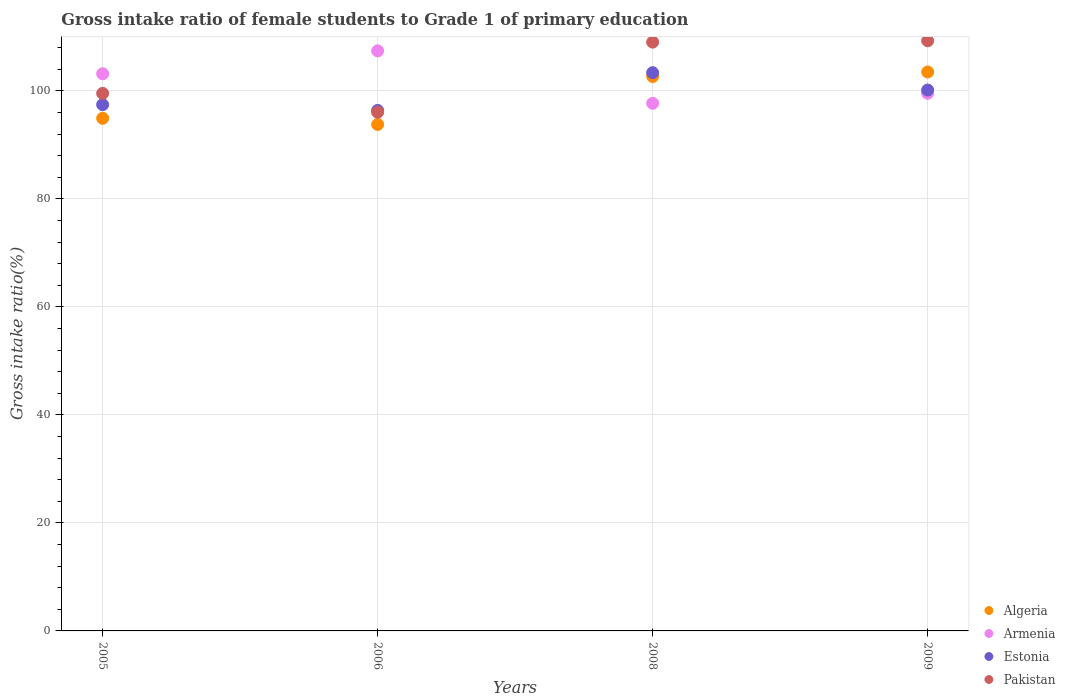How many different coloured dotlines are there?
Give a very brief answer. 4. Is the number of dotlines equal to the number of legend labels?
Your answer should be compact. Yes. What is the gross intake ratio in Armenia in 2006?
Your response must be concise. 107.41. Across all years, what is the maximum gross intake ratio in Armenia?
Your answer should be very brief. 107.41. Across all years, what is the minimum gross intake ratio in Estonia?
Your answer should be very brief. 96.38. In which year was the gross intake ratio in Pakistan maximum?
Give a very brief answer. 2009. What is the total gross intake ratio in Pakistan in the graph?
Offer a terse response. 413.89. What is the difference between the gross intake ratio in Estonia in 2005 and that in 2006?
Offer a terse response. 1.06. What is the difference between the gross intake ratio in Pakistan in 2006 and the gross intake ratio in Algeria in 2008?
Make the answer very short. -6.61. What is the average gross intake ratio in Armenia per year?
Provide a short and direct response. 101.96. In the year 2009, what is the difference between the gross intake ratio in Estonia and gross intake ratio in Algeria?
Make the answer very short. -3.35. What is the ratio of the gross intake ratio in Pakistan in 2005 to that in 2006?
Give a very brief answer. 1.04. Is the difference between the gross intake ratio in Estonia in 2006 and 2009 greater than the difference between the gross intake ratio in Algeria in 2006 and 2009?
Provide a short and direct response. Yes. What is the difference between the highest and the second highest gross intake ratio in Pakistan?
Make the answer very short. 0.25. What is the difference between the highest and the lowest gross intake ratio in Armenia?
Keep it short and to the point. 9.71. In how many years, is the gross intake ratio in Algeria greater than the average gross intake ratio in Algeria taken over all years?
Your answer should be very brief. 2. Is the sum of the gross intake ratio in Armenia in 2005 and 2008 greater than the maximum gross intake ratio in Pakistan across all years?
Your response must be concise. Yes. Does the gross intake ratio in Armenia monotonically increase over the years?
Your response must be concise. No. How many dotlines are there?
Give a very brief answer. 4. How many years are there in the graph?
Provide a succinct answer. 4. Where does the legend appear in the graph?
Your answer should be very brief. Bottom right. How many legend labels are there?
Make the answer very short. 4. What is the title of the graph?
Your answer should be compact. Gross intake ratio of female students to Grade 1 of primary education. Does "East Asia (developing only)" appear as one of the legend labels in the graph?
Make the answer very short. No. What is the label or title of the X-axis?
Offer a very short reply. Years. What is the label or title of the Y-axis?
Your answer should be compact. Gross intake ratio(%). What is the Gross intake ratio(%) of Algeria in 2005?
Offer a terse response. 94.92. What is the Gross intake ratio(%) in Armenia in 2005?
Keep it short and to the point. 103.16. What is the Gross intake ratio(%) of Estonia in 2005?
Offer a terse response. 97.45. What is the Gross intake ratio(%) of Pakistan in 2005?
Make the answer very short. 99.54. What is the Gross intake ratio(%) of Algeria in 2006?
Provide a succinct answer. 93.78. What is the Gross intake ratio(%) of Armenia in 2006?
Give a very brief answer. 107.41. What is the Gross intake ratio(%) in Estonia in 2006?
Your response must be concise. 96.38. What is the Gross intake ratio(%) of Pakistan in 2006?
Your answer should be very brief. 96.05. What is the Gross intake ratio(%) of Algeria in 2008?
Give a very brief answer. 102.66. What is the Gross intake ratio(%) of Armenia in 2008?
Provide a succinct answer. 97.7. What is the Gross intake ratio(%) in Estonia in 2008?
Make the answer very short. 103.37. What is the Gross intake ratio(%) in Pakistan in 2008?
Your response must be concise. 109.03. What is the Gross intake ratio(%) in Algeria in 2009?
Provide a succinct answer. 103.5. What is the Gross intake ratio(%) of Armenia in 2009?
Provide a short and direct response. 99.56. What is the Gross intake ratio(%) in Estonia in 2009?
Provide a succinct answer. 100.15. What is the Gross intake ratio(%) in Pakistan in 2009?
Provide a succinct answer. 109.28. Across all years, what is the maximum Gross intake ratio(%) of Algeria?
Make the answer very short. 103.5. Across all years, what is the maximum Gross intake ratio(%) of Armenia?
Your answer should be compact. 107.41. Across all years, what is the maximum Gross intake ratio(%) of Estonia?
Provide a short and direct response. 103.37. Across all years, what is the maximum Gross intake ratio(%) of Pakistan?
Keep it short and to the point. 109.28. Across all years, what is the minimum Gross intake ratio(%) of Algeria?
Ensure brevity in your answer.  93.78. Across all years, what is the minimum Gross intake ratio(%) of Armenia?
Your answer should be very brief. 97.7. Across all years, what is the minimum Gross intake ratio(%) of Estonia?
Provide a succinct answer. 96.38. Across all years, what is the minimum Gross intake ratio(%) of Pakistan?
Your answer should be compact. 96.05. What is the total Gross intake ratio(%) of Algeria in the graph?
Provide a short and direct response. 394.86. What is the total Gross intake ratio(%) of Armenia in the graph?
Provide a short and direct response. 407.83. What is the total Gross intake ratio(%) in Estonia in the graph?
Your response must be concise. 397.35. What is the total Gross intake ratio(%) in Pakistan in the graph?
Provide a succinct answer. 413.89. What is the difference between the Gross intake ratio(%) in Algeria in 2005 and that in 2006?
Your answer should be compact. 1.14. What is the difference between the Gross intake ratio(%) of Armenia in 2005 and that in 2006?
Offer a very short reply. -4.25. What is the difference between the Gross intake ratio(%) of Estonia in 2005 and that in 2006?
Keep it short and to the point. 1.06. What is the difference between the Gross intake ratio(%) in Pakistan in 2005 and that in 2006?
Provide a succinct answer. 3.49. What is the difference between the Gross intake ratio(%) of Algeria in 2005 and that in 2008?
Make the answer very short. -7.74. What is the difference between the Gross intake ratio(%) in Armenia in 2005 and that in 2008?
Keep it short and to the point. 5.46. What is the difference between the Gross intake ratio(%) in Estonia in 2005 and that in 2008?
Keep it short and to the point. -5.92. What is the difference between the Gross intake ratio(%) in Pakistan in 2005 and that in 2008?
Provide a succinct answer. -9.49. What is the difference between the Gross intake ratio(%) of Algeria in 2005 and that in 2009?
Make the answer very short. -8.58. What is the difference between the Gross intake ratio(%) of Armenia in 2005 and that in 2009?
Your answer should be very brief. 3.61. What is the difference between the Gross intake ratio(%) in Estonia in 2005 and that in 2009?
Provide a short and direct response. -2.7. What is the difference between the Gross intake ratio(%) in Pakistan in 2005 and that in 2009?
Provide a succinct answer. -9.74. What is the difference between the Gross intake ratio(%) in Algeria in 2006 and that in 2008?
Offer a terse response. -8.88. What is the difference between the Gross intake ratio(%) in Armenia in 2006 and that in 2008?
Make the answer very short. 9.71. What is the difference between the Gross intake ratio(%) in Estonia in 2006 and that in 2008?
Ensure brevity in your answer.  -6.99. What is the difference between the Gross intake ratio(%) of Pakistan in 2006 and that in 2008?
Ensure brevity in your answer.  -12.98. What is the difference between the Gross intake ratio(%) of Algeria in 2006 and that in 2009?
Your answer should be very brief. -9.72. What is the difference between the Gross intake ratio(%) in Armenia in 2006 and that in 2009?
Your answer should be very brief. 7.85. What is the difference between the Gross intake ratio(%) of Estonia in 2006 and that in 2009?
Keep it short and to the point. -3.77. What is the difference between the Gross intake ratio(%) of Pakistan in 2006 and that in 2009?
Your answer should be very brief. -13.23. What is the difference between the Gross intake ratio(%) of Algeria in 2008 and that in 2009?
Provide a short and direct response. -0.83. What is the difference between the Gross intake ratio(%) in Armenia in 2008 and that in 2009?
Provide a short and direct response. -1.85. What is the difference between the Gross intake ratio(%) of Estonia in 2008 and that in 2009?
Offer a terse response. 3.22. What is the difference between the Gross intake ratio(%) in Pakistan in 2008 and that in 2009?
Provide a succinct answer. -0.25. What is the difference between the Gross intake ratio(%) in Algeria in 2005 and the Gross intake ratio(%) in Armenia in 2006?
Make the answer very short. -12.49. What is the difference between the Gross intake ratio(%) in Algeria in 2005 and the Gross intake ratio(%) in Estonia in 2006?
Provide a succinct answer. -1.46. What is the difference between the Gross intake ratio(%) in Algeria in 2005 and the Gross intake ratio(%) in Pakistan in 2006?
Offer a very short reply. -1.13. What is the difference between the Gross intake ratio(%) of Armenia in 2005 and the Gross intake ratio(%) of Estonia in 2006?
Your answer should be very brief. 6.78. What is the difference between the Gross intake ratio(%) of Armenia in 2005 and the Gross intake ratio(%) of Pakistan in 2006?
Keep it short and to the point. 7.11. What is the difference between the Gross intake ratio(%) in Estonia in 2005 and the Gross intake ratio(%) in Pakistan in 2006?
Offer a very short reply. 1.4. What is the difference between the Gross intake ratio(%) of Algeria in 2005 and the Gross intake ratio(%) of Armenia in 2008?
Offer a very short reply. -2.78. What is the difference between the Gross intake ratio(%) in Algeria in 2005 and the Gross intake ratio(%) in Estonia in 2008?
Keep it short and to the point. -8.45. What is the difference between the Gross intake ratio(%) in Algeria in 2005 and the Gross intake ratio(%) in Pakistan in 2008?
Keep it short and to the point. -14.11. What is the difference between the Gross intake ratio(%) in Armenia in 2005 and the Gross intake ratio(%) in Estonia in 2008?
Your answer should be compact. -0.21. What is the difference between the Gross intake ratio(%) of Armenia in 2005 and the Gross intake ratio(%) of Pakistan in 2008?
Offer a very short reply. -5.87. What is the difference between the Gross intake ratio(%) in Estonia in 2005 and the Gross intake ratio(%) in Pakistan in 2008?
Keep it short and to the point. -11.58. What is the difference between the Gross intake ratio(%) in Algeria in 2005 and the Gross intake ratio(%) in Armenia in 2009?
Your response must be concise. -4.64. What is the difference between the Gross intake ratio(%) of Algeria in 2005 and the Gross intake ratio(%) of Estonia in 2009?
Your answer should be very brief. -5.23. What is the difference between the Gross intake ratio(%) in Algeria in 2005 and the Gross intake ratio(%) in Pakistan in 2009?
Your response must be concise. -14.36. What is the difference between the Gross intake ratio(%) of Armenia in 2005 and the Gross intake ratio(%) of Estonia in 2009?
Make the answer very short. 3.01. What is the difference between the Gross intake ratio(%) of Armenia in 2005 and the Gross intake ratio(%) of Pakistan in 2009?
Make the answer very short. -6.12. What is the difference between the Gross intake ratio(%) in Estonia in 2005 and the Gross intake ratio(%) in Pakistan in 2009?
Provide a short and direct response. -11.83. What is the difference between the Gross intake ratio(%) of Algeria in 2006 and the Gross intake ratio(%) of Armenia in 2008?
Your answer should be compact. -3.92. What is the difference between the Gross intake ratio(%) of Algeria in 2006 and the Gross intake ratio(%) of Estonia in 2008?
Keep it short and to the point. -9.59. What is the difference between the Gross intake ratio(%) in Algeria in 2006 and the Gross intake ratio(%) in Pakistan in 2008?
Your answer should be compact. -15.25. What is the difference between the Gross intake ratio(%) in Armenia in 2006 and the Gross intake ratio(%) in Estonia in 2008?
Offer a very short reply. 4.04. What is the difference between the Gross intake ratio(%) of Armenia in 2006 and the Gross intake ratio(%) of Pakistan in 2008?
Ensure brevity in your answer.  -1.62. What is the difference between the Gross intake ratio(%) in Estonia in 2006 and the Gross intake ratio(%) in Pakistan in 2008?
Ensure brevity in your answer.  -12.64. What is the difference between the Gross intake ratio(%) of Algeria in 2006 and the Gross intake ratio(%) of Armenia in 2009?
Offer a terse response. -5.77. What is the difference between the Gross intake ratio(%) in Algeria in 2006 and the Gross intake ratio(%) in Estonia in 2009?
Your response must be concise. -6.37. What is the difference between the Gross intake ratio(%) in Algeria in 2006 and the Gross intake ratio(%) in Pakistan in 2009?
Provide a succinct answer. -15.5. What is the difference between the Gross intake ratio(%) in Armenia in 2006 and the Gross intake ratio(%) in Estonia in 2009?
Your answer should be very brief. 7.26. What is the difference between the Gross intake ratio(%) in Armenia in 2006 and the Gross intake ratio(%) in Pakistan in 2009?
Provide a succinct answer. -1.87. What is the difference between the Gross intake ratio(%) of Estonia in 2006 and the Gross intake ratio(%) of Pakistan in 2009?
Give a very brief answer. -12.9. What is the difference between the Gross intake ratio(%) in Algeria in 2008 and the Gross intake ratio(%) in Armenia in 2009?
Your response must be concise. 3.11. What is the difference between the Gross intake ratio(%) of Algeria in 2008 and the Gross intake ratio(%) of Estonia in 2009?
Provide a succinct answer. 2.51. What is the difference between the Gross intake ratio(%) in Algeria in 2008 and the Gross intake ratio(%) in Pakistan in 2009?
Offer a terse response. -6.62. What is the difference between the Gross intake ratio(%) in Armenia in 2008 and the Gross intake ratio(%) in Estonia in 2009?
Offer a terse response. -2.45. What is the difference between the Gross intake ratio(%) of Armenia in 2008 and the Gross intake ratio(%) of Pakistan in 2009?
Offer a terse response. -11.58. What is the difference between the Gross intake ratio(%) of Estonia in 2008 and the Gross intake ratio(%) of Pakistan in 2009?
Offer a very short reply. -5.91. What is the average Gross intake ratio(%) in Algeria per year?
Provide a short and direct response. 98.72. What is the average Gross intake ratio(%) in Armenia per year?
Provide a succinct answer. 101.96. What is the average Gross intake ratio(%) of Estonia per year?
Your response must be concise. 99.34. What is the average Gross intake ratio(%) in Pakistan per year?
Ensure brevity in your answer.  103.47. In the year 2005, what is the difference between the Gross intake ratio(%) in Algeria and Gross intake ratio(%) in Armenia?
Your response must be concise. -8.24. In the year 2005, what is the difference between the Gross intake ratio(%) in Algeria and Gross intake ratio(%) in Estonia?
Offer a very short reply. -2.53. In the year 2005, what is the difference between the Gross intake ratio(%) of Algeria and Gross intake ratio(%) of Pakistan?
Provide a succinct answer. -4.62. In the year 2005, what is the difference between the Gross intake ratio(%) in Armenia and Gross intake ratio(%) in Estonia?
Your answer should be compact. 5.71. In the year 2005, what is the difference between the Gross intake ratio(%) in Armenia and Gross intake ratio(%) in Pakistan?
Your answer should be compact. 3.62. In the year 2005, what is the difference between the Gross intake ratio(%) in Estonia and Gross intake ratio(%) in Pakistan?
Offer a terse response. -2.09. In the year 2006, what is the difference between the Gross intake ratio(%) of Algeria and Gross intake ratio(%) of Armenia?
Your response must be concise. -13.63. In the year 2006, what is the difference between the Gross intake ratio(%) of Algeria and Gross intake ratio(%) of Estonia?
Keep it short and to the point. -2.6. In the year 2006, what is the difference between the Gross intake ratio(%) of Algeria and Gross intake ratio(%) of Pakistan?
Provide a short and direct response. -2.27. In the year 2006, what is the difference between the Gross intake ratio(%) in Armenia and Gross intake ratio(%) in Estonia?
Ensure brevity in your answer.  11.02. In the year 2006, what is the difference between the Gross intake ratio(%) of Armenia and Gross intake ratio(%) of Pakistan?
Keep it short and to the point. 11.36. In the year 2006, what is the difference between the Gross intake ratio(%) in Estonia and Gross intake ratio(%) in Pakistan?
Ensure brevity in your answer.  0.33. In the year 2008, what is the difference between the Gross intake ratio(%) of Algeria and Gross intake ratio(%) of Armenia?
Your answer should be very brief. 4.96. In the year 2008, what is the difference between the Gross intake ratio(%) of Algeria and Gross intake ratio(%) of Estonia?
Your response must be concise. -0.71. In the year 2008, what is the difference between the Gross intake ratio(%) in Algeria and Gross intake ratio(%) in Pakistan?
Keep it short and to the point. -6.36. In the year 2008, what is the difference between the Gross intake ratio(%) in Armenia and Gross intake ratio(%) in Estonia?
Your answer should be very brief. -5.67. In the year 2008, what is the difference between the Gross intake ratio(%) in Armenia and Gross intake ratio(%) in Pakistan?
Offer a very short reply. -11.33. In the year 2008, what is the difference between the Gross intake ratio(%) in Estonia and Gross intake ratio(%) in Pakistan?
Offer a terse response. -5.65. In the year 2009, what is the difference between the Gross intake ratio(%) in Algeria and Gross intake ratio(%) in Armenia?
Provide a succinct answer. 3.94. In the year 2009, what is the difference between the Gross intake ratio(%) of Algeria and Gross intake ratio(%) of Estonia?
Your response must be concise. 3.35. In the year 2009, what is the difference between the Gross intake ratio(%) in Algeria and Gross intake ratio(%) in Pakistan?
Your answer should be compact. -5.78. In the year 2009, what is the difference between the Gross intake ratio(%) in Armenia and Gross intake ratio(%) in Estonia?
Give a very brief answer. -0.6. In the year 2009, what is the difference between the Gross intake ratio(%) of Armenia and Gross intake ratio(%) of Pakistan?
Your answer should be compact. -9.72. In the year 2009, what is the difference between the Gross intake ratio(%) in Estonia and Gross intake ratio(%) in Pakistan?
Offer a terse response. -9.13. What is the ratio of the Gross intake ratio(%) of Algeria in 2005 to that in 2006?
Keep it short and to the point. 1.01. What is the ratio of the Gross intake ratio(%) in Armenia in 2005 to that in 2006?
Offer a very short reply. 0.96. What is the ratio of the Gross intake ratio(%) of Estonia in 2005 to that in 2006?
Provide a short and direct response. 1.01. What is the ratio of the Gross intake ratio(%) of Pakistan in 2005 to that in 2006?
Make the answer very short. 1.04. What is the ratio of the Gross intake ratio(%) in Algeria in 2005 to that in 2008?
Keep it short and to the point. 0.92. What is the ratio of the Gross intake ratio(%) in Armenia in 2005 to that in 2008?
Make the answer very short. 1.06. What is the ratio of the Gross intake ratio(%) of Estonia in 2005 to that in 2008?
Your response must be concise. 0.94. What is the ratio of the Gross intake ratio(%) of Pakistan in 2005 to that in 2008?
Offer a very short reply. 0.91. What is the ratio of the Gross intake ratio(%) in Algeria in 2005 to that in 2009?
Offer a very short reply. 0.92. What is the ratio of the Gross intake ratio(%) of Armenia in 2005 to that in 2009?
Keep it short and to the point. 1.04. What is the ratio of the Gross intake ratio(%) in Pakistan in 2005 to that in 2009?
Your response must be concise. 0.91. What is the ratio of the Gross intake ratio(%) of Algeria in 2006 to that in 2008?
Provide a succinct answer. 0.91. What is the ratio of the Gross intake ratio(%) of Armenia in 2006 to that in 2008?
Offer a terse response. 1.1. What is the ratio of the Gross intake ratio(%) of Estonia in 2006 to that in 2008?
Keep it short and to the point. 0.93. What is the ratio of the Gross intake ratio(%) in Pakistan in 2006 to that in 2008?
Give a very brief answer. 0.88. What is the ratio of the Gross intake ratio(%) in Algeria in 2006 to that in 2009?
Your answer should be very brief. 0.91. What is the ratio of the Gross intake ratio(%) in Armenia in 2006 to that in 2009?
Offer a terse response. 1.08. What is the ratio of the Gross intake ratio(%) in Estonia in 2006 to that in 2009?
Make the answer very short. 0.96. What is the ratio of the Gross intake ratio(%) in Pakistan in 2006 to that in 2009?
Offer a very short reply. 0.88. What is the ratio of the Gross intake ratio(%) in Armenia in 2008 to that in 2009?
Your answer should be compact. 0.98. What is the ratio of the Gross intake ratio(%) of Estonia in 2008 to that in 2009?
Offer a very short reply. 1.03. What is the ratio of the Gross intake ratio(%) of Pakistan in 2008 to that in 2009?
Offer a terse response. 1. What is the difference between the highest and the second highest Gross intake ratio(%) in Algeria?
Give a very brief answer. 0.83. What is the difference between the highest and the second highest Gross intake ratio(%) in Armenia?
Your response must be concise. 4.25. What is the difference between the highest and the second highest Gross intake ratio(%) in Estonia?
Keep it short and to the point. 3.22. What is the difference between the highest and the second highest Gross intake ratio(%) in Pakistan?
Give a very brief answer. 0.25. What is the difference between the highest and the lowest Gross intake ratio(%) in Algeria?
Ensure brevity in your answer.  9.72. What is the difference between the highest and the lowest Gross intake ratio(%) in Armenia?
Your answer should be compact. 9.71. What is the difference between the highest and the lowest Gross intake ratio(%) in Estonia?
Provide a short and direct response. 6.99. What is the difference between the highest and the lowest Gross intake ratio(%) of Pakistan?
Offer a very short reply. 13.23. 